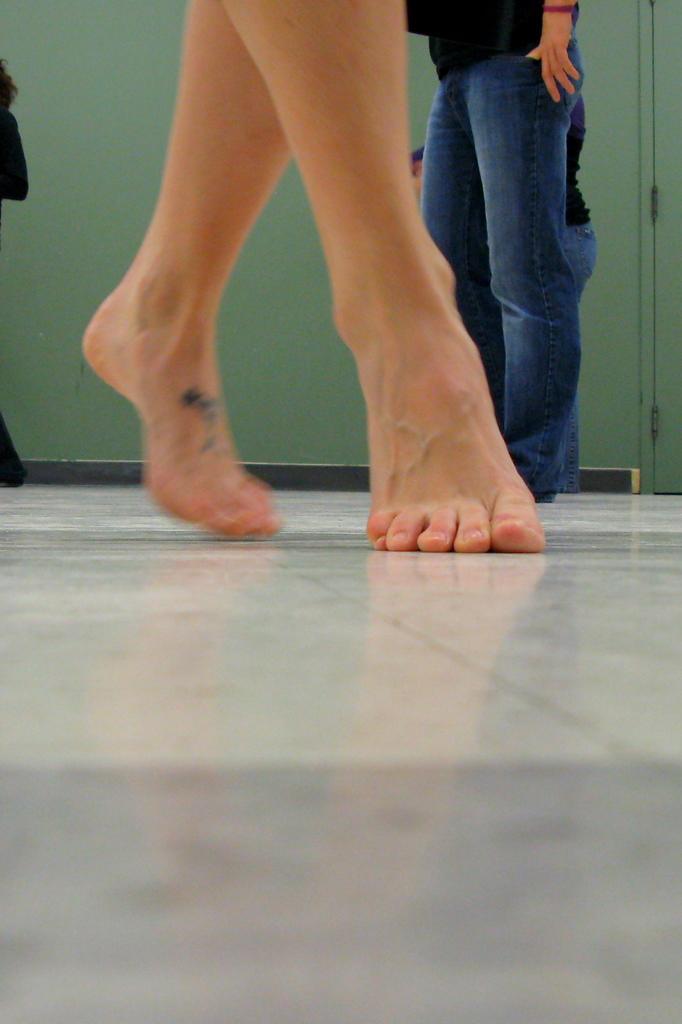How would you summarize this image in a sentence or two? In this image we can see the person's legs who is standing on the toes. In the background there is another person who is standing on the floor. Behind the person there is a wall. 